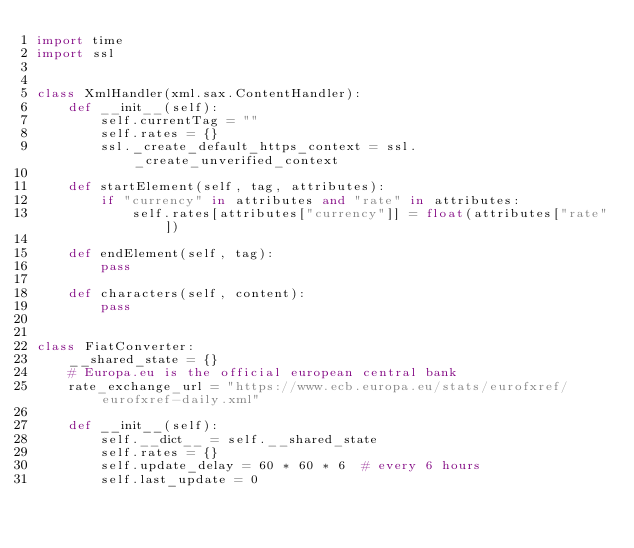Convert code to text. <code><loc_0><loc_0><loc_500><loc_500><_Python_>import time
import ssl


class XmlHandler(xml.sax.ContentHandler):
    def __init__(self):
        self.currentTag = ""
        self.rates = {}
        ssl._create_default_https_context = ssl._create_unverified_context

    def startElement(self, tag, attributes):
        if "currency" in attributes and "rate" in attributes:
            self.rates[attributes["currency"]] = float(attributes["rate"])

    def endElement(self, tag):
        pass

    def characters(self, content):
        pass


class FiatConverter:
    __shared_state = {}
    # Europa.eu is the official european central bank
    rate_exchange_url = "https://www.ecb.europa.eu/stats/eurofxref/eurofxref-daily.xml"

    def __init__(self):
        self.__dict__ = self.__shared_state
        self.rates = {}
        self.update_delay = 60 * 60 * 6  # every 6 hours
        self.last_update = 0</code> 